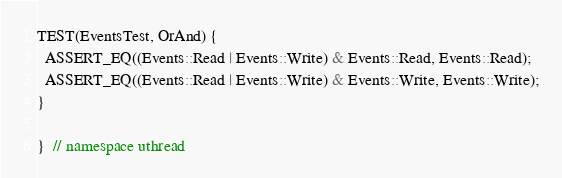<code> <loc_0><loc_0><loc_500><loc_500><_C++_>TEST(EventsTest, OrAnd) {
  ASSERT_EQ((Events::Read | Events::Write) & Events::Read, Events::Read);
  ASSERT_EQ((Events::Read | Events::Write) & Events::Write, Events::Write);
}

}  // namespace uthread
</code> 